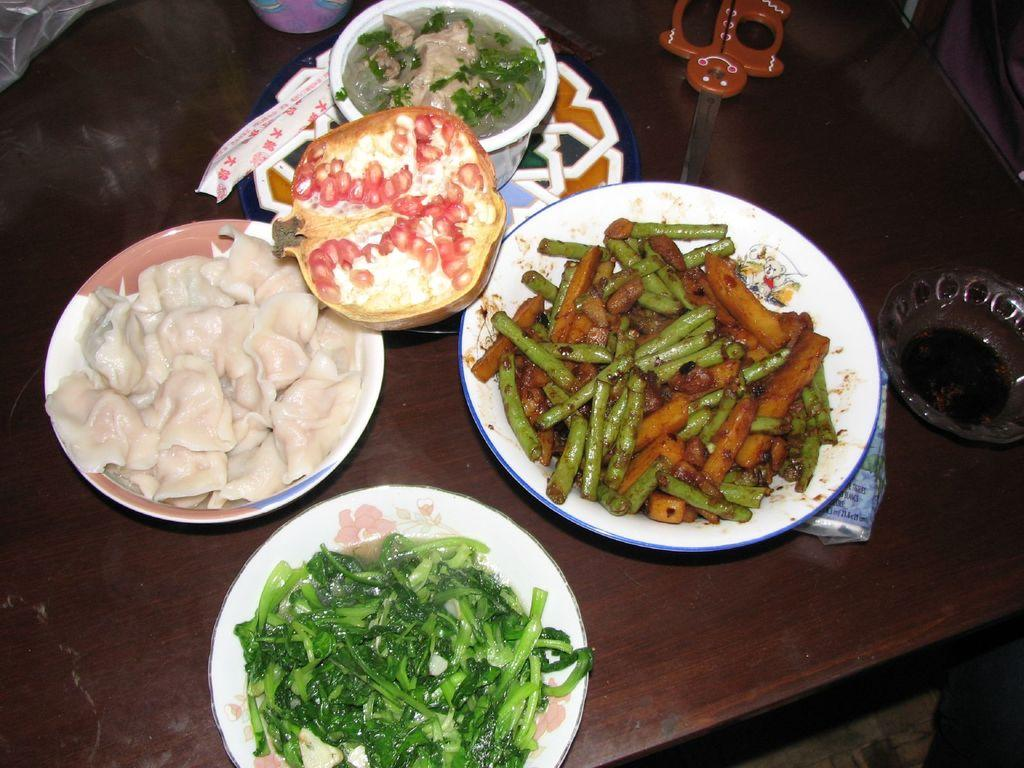What can be seen on the plates in the image? There are plates with food items in the image. What type of containers are also present in the image? There are bowls in the image. What tool is visible in the image? There is a scissor in the image. What is the surface made of that the objects are placed on? The objects are placed on a wooden surface in the image. How does the scissor play with the food items in the image? The scissor does not play with the food items in the image; it is a tool and not animate. 